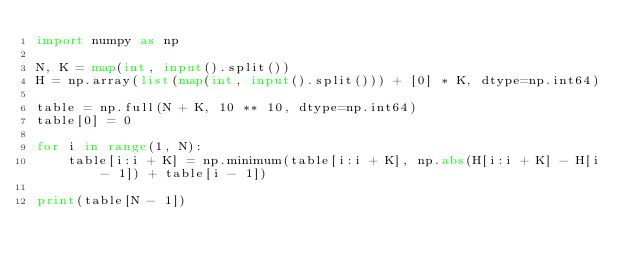<code> <loc_0><loc_0><loc_500><loc_500><_Python_>import numpy as np

N, K = map(int, input().split())
H = np.array(list(map(int, input().split())) + [0] * K, dtype=np.int64)

table = np.full(N + K, 10 ** 10, dtype=np.int64)
table[0] = 0

for i in range(1, N):
    table[i:i + K] = np.minimum(table[i:i + K], np.abs(H[i:i + K] - H[i - 1]) + table[i - 1])

print(table[N - 1])
</code> 